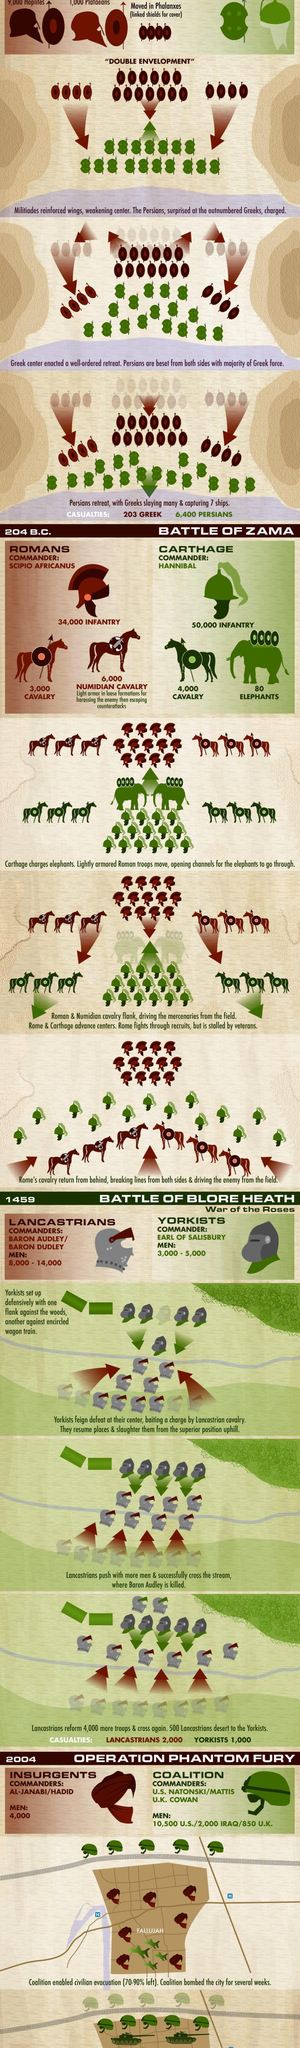Highlight a few significant elements in this photo. The Battle of Blore Heath took place in 1459. The Lancastrians had more causalities during the battle of Blore Heath. The Coalition had more strength during Operation Phantom Fury than the other party. During the battle of Blore Heath, the Lancastrians had more strength than the Yorkists. Carthage had more infantry during the Battle of Zama than Rome. 